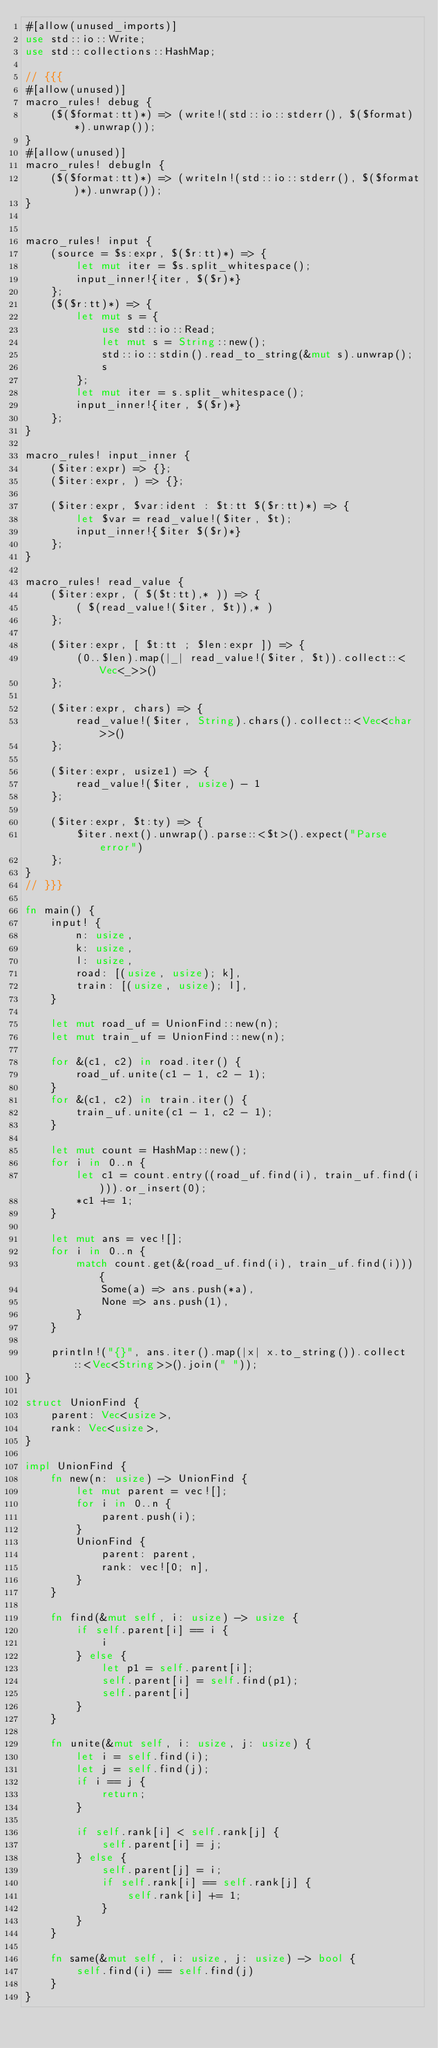Convert code to text. <code><loc_0><loc_0><loc_500><loc_500><_Rust_>#[allow(unused_imports)]
use std::io::Write;
use std::collections::HashMap;

// {{{
#[allow(unused)]
macro_rules! debug {
    ($($format:tt)*) => (write!(std::io::stderr(), $($format)*).unwrap());
}
#[allow(unused)]
macro_rules! debugln {
    ($($format:tt)*) => (writeln!(std::io::stderr(), $($format)*).unwrap());
}


macro_rules! input {
    (source = $s:expr, $($r:tt)*) => {
        let mut iter = $s.split_whitespace();
        input_inner!{iter, $($r)*}
    };
    ($($r:tt)*) => {
        let mut s = {
            use std::io::Read;
            let mut s = String::new();
            std::io::stdin().read_to_string(&mut s).unwrap();
            s
        };
        let mut iter = s.split_whitespace();
        input_inner!{iter, $($r)*}
    };
}

macro_rules! input_inner {
    ($iter:expr) => {};
    ($iter:expr, ) => {};

    ($iter:expr, $var:ident : $t:tt $($r:tt)*) => {
        let $var = read_value!($iter, $t);
        input_inner!{$iter $($r)*}
    };
}

macro_rules! read_value {
    ($iter:expr, ( $($t:tt),* )) => {
        ( $(read_value!($iter, $t)),* )
    };

    ($iter:expr, [ $t:tt ; $len:expr ]) => {
        (0..$len).map(|_| read_value!($iter, $t)).collect::<Vec<_>>()
    };

    ($iter:expr, chars) => {
        read_value!($iter, String).chars().collect::<Vec<char>>()
    };

    ($iter:expr, usize1) => {
        read_value!($iter, usize) - 1
    };

    ($iter:expr, $t:ty) => {
        $iter.next().unwrap().parse::<$t>().expect("Parse error")
    };
}
// }}}

fn main() {
    input! {
        n: usize,
        k: usize,
        l: usize,
        road: [(usize, usize); k],
        train: [(usize, usize); l],
    }

    let mut road_uf = UnionFind::new(n);
    let mut train_uf = UnionFind::new(n);

    for &(c1, c2) in road.iter() {
        road_uf.unite(c1 - 1, c2 - 1);
    }
    for &(c1, c2) in train.iter() {
        train_uf.unite(c1 - 1, c2 - 1);
    }

    let mut count = HashMap::new();
    for i in 0..n {
        let c1 = count.entry((road_uf.find(i), train_uf.find(i))).or_insert(0);
        *c1 += 1;
    }

    let mut ans = vec![];
    for i in 0..n {
        match count.get(&(road_uf.find(i), train_uf.find(i))) {
            Some(a) => ans.push(*a),
            None => ans.push(1),
        }
    }

    println!("{}", ans.iter().map(|x| x.to_string()).collect::<Vec<String>>().join(" "));
}

struct UnionFind {
    parent: Vec<usize>,
    rank: Vec<usize>,
}

impl UnionFind {
    fn new(n: usize) -> UnionFind {
        let mut parent = vec![];
        for i in 0..n {
            parent.push(i);
        }
        UnionFind {
            parent: parent,
            rank: vec![0; n],
        }
    }

    fn find(&mut self, i: usize) -> usize {
        if self.parent[i] == i {
            i
        } else {
            let p1 = self.parent[i];
            self.parent[i] = self.find(p1);
            self.parent[i]
        }
    }

    fn unite(&mut self, i: usize, j: usize) {
        let i = self.find(i);
        let j = self.find(j);
        if i == j {
            return;
        }

        if self.rank[i] < self.rank[j] {
            self.parent[i] = j;
        } else {
            self.parent[j] = i;
            if self.rank[i] == self.rank[j] {
                self.rank[i] += 1;
            }
        }
    }

    fn same(&mut self, i: usize, j: usize) -> bool {
        self.find(i) == self.find(j)
    }
}
</code> 